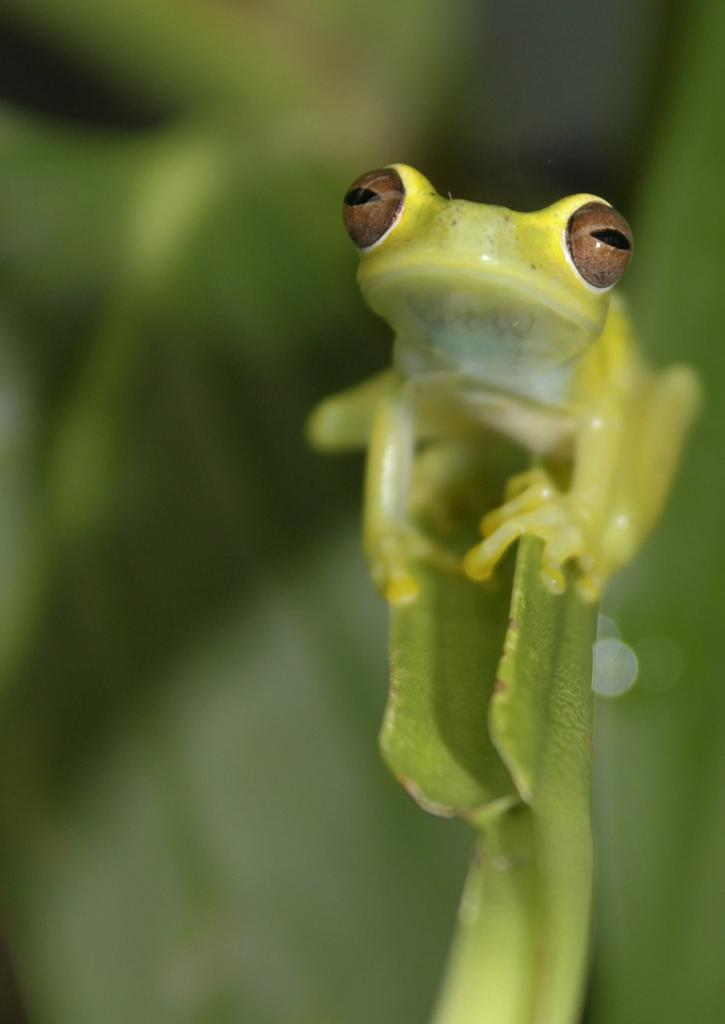What animal is present in the image? There is a frog in the image. What colors can be seen on the frog? The frog has green, yellow, brown, and black colors. Where is the frog located in the image? The frog is on a leaf. What color is the leaf? The leaf is green in color. What is the background of the image? The background of the image is green. What decision does the frog make in the image? There is no indication in the image that the frog is making a decision. How many chairs are visible in the image? There are no chairs present in the image. 